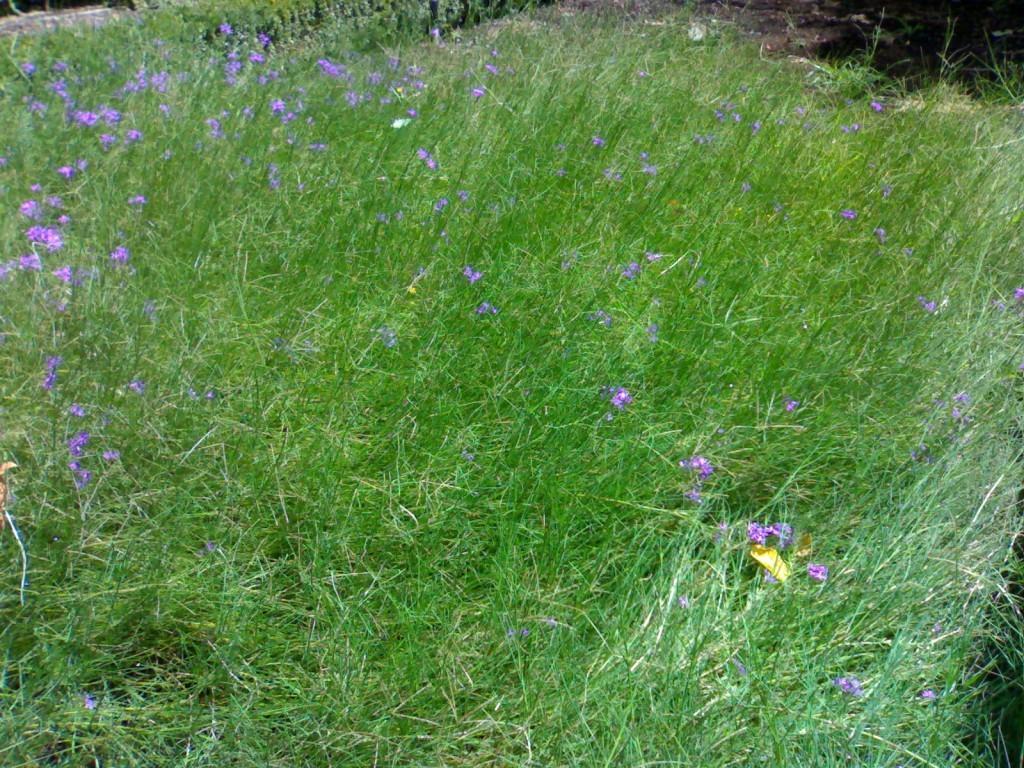Describe this image in one or two sentences. In this picture we can see some grass, flowers are present. At the top right corner ground is there. 